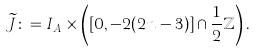Convert formula to latex. <formula><loc_0><loc_0><loc_500><loc_500>\widetilde { J } \colon = I _ { A } \times \left ( [ 0 , - 2 ( 2 n - 3 ) ] \cap \frac { 1 } { 2 } \mathbb { Z } \right ) .</formula> 